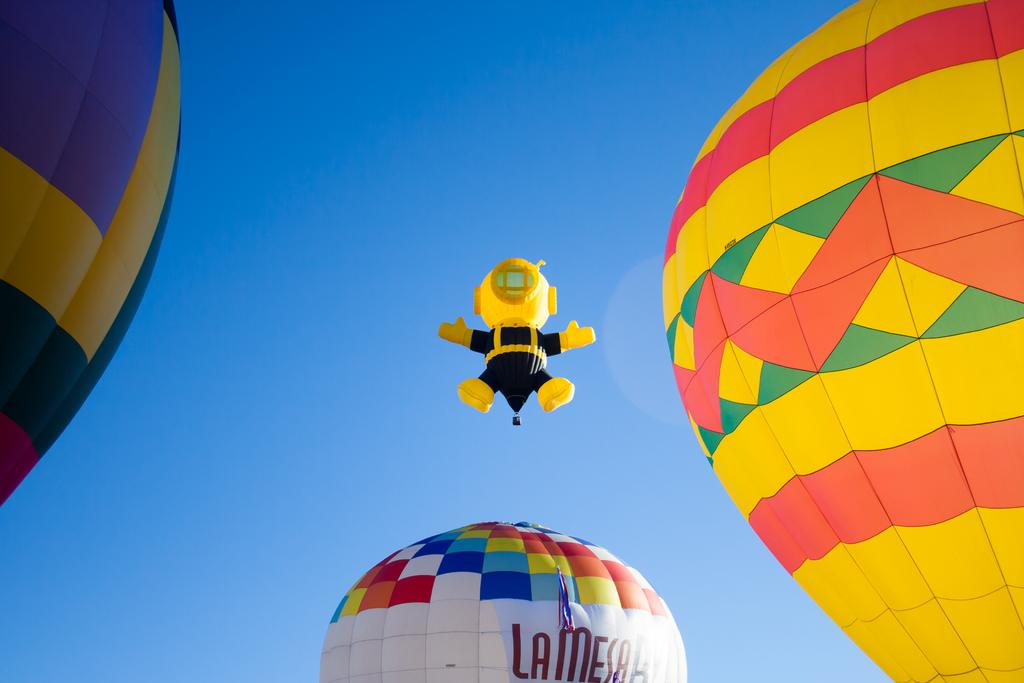What brand is the white balloon?
Provide a succinct answer. Lamesa. 